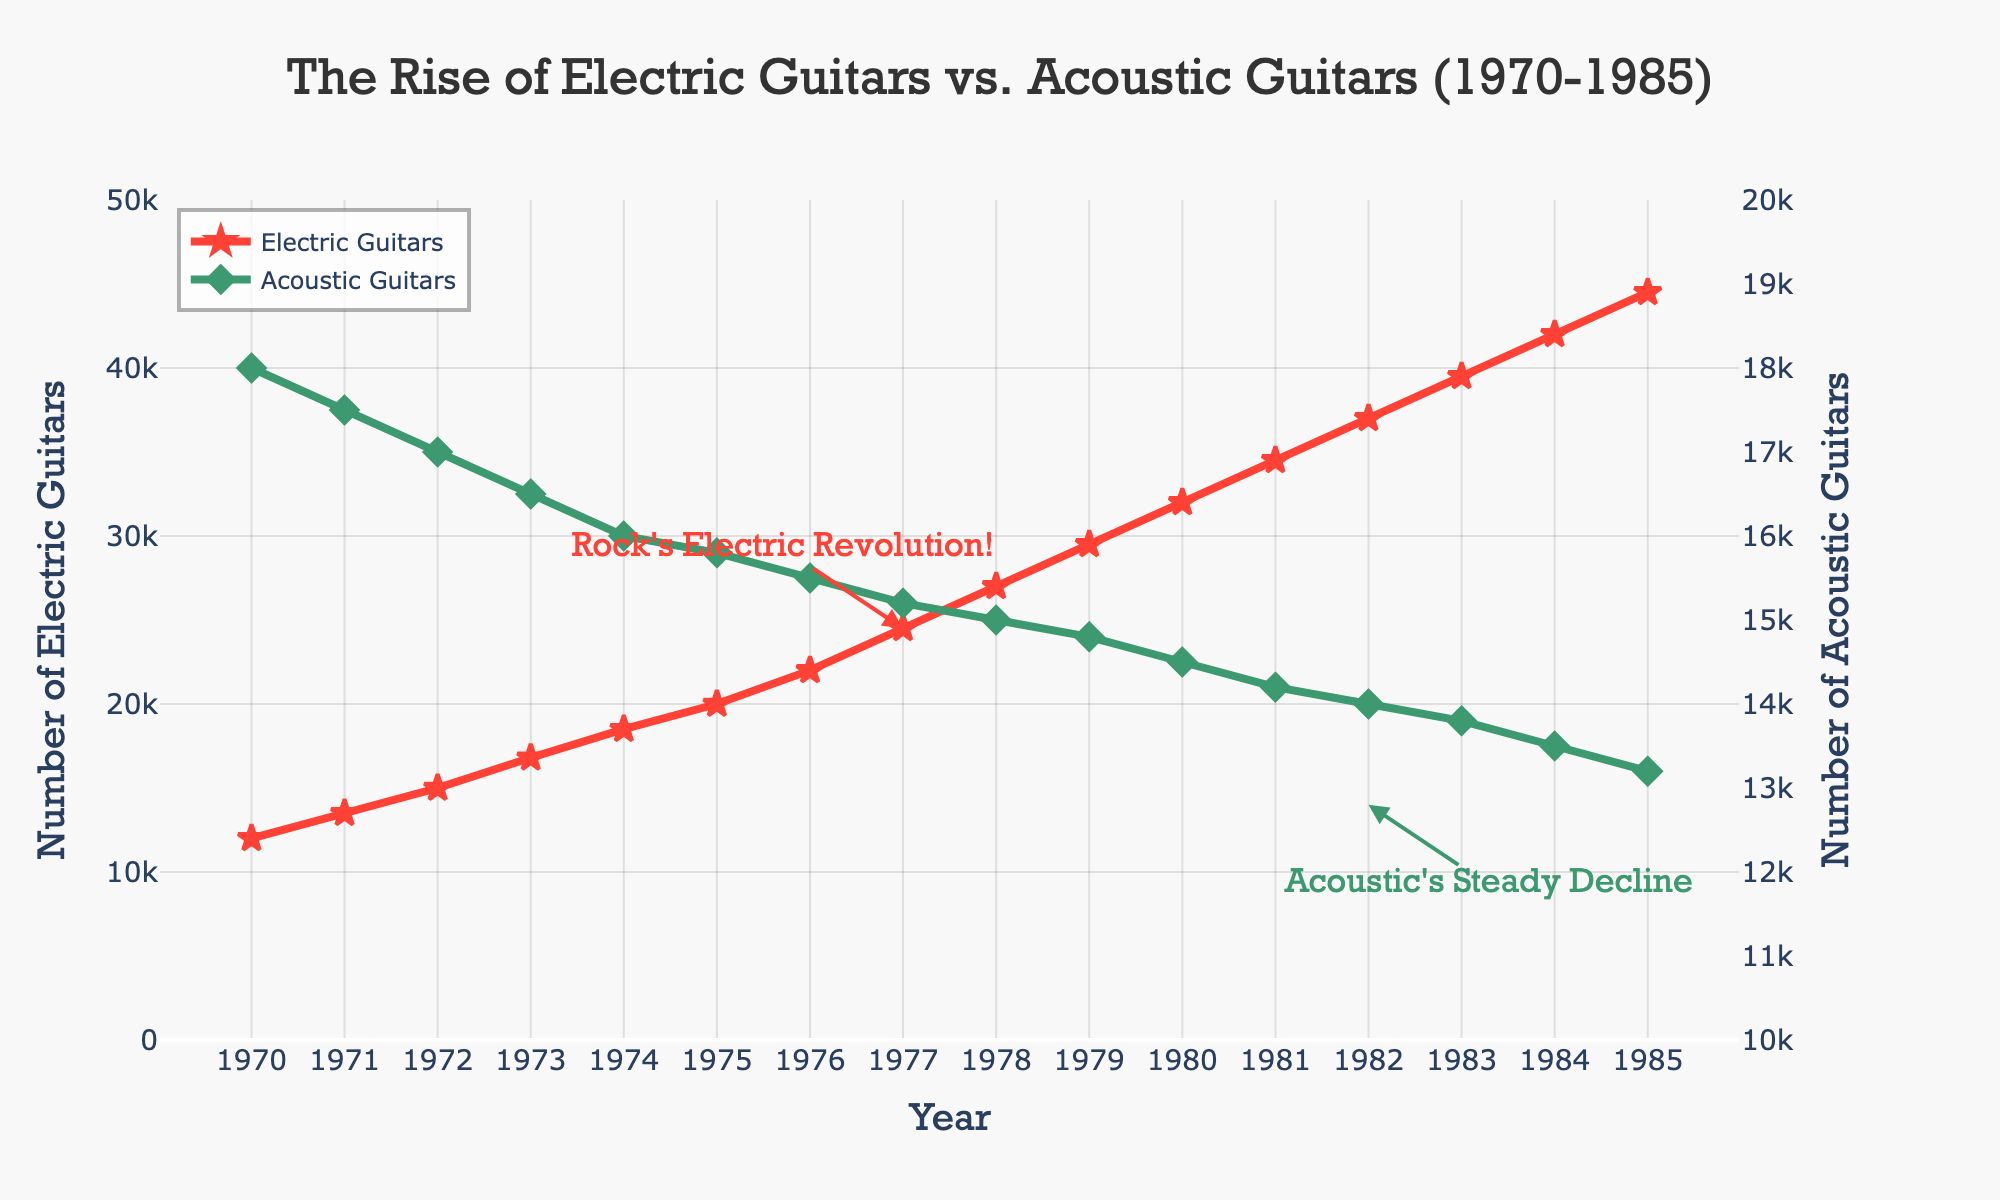What is the general trend of electric guitar sales from 1970 to 1985? The figure shows a consistent upward trend in the sales of electric guitars, starting at 12,000 in 1970 and reaching 44,500 in 1985. This indicates a strong and steady increase over the 15-year span.
Answer: Steady increase How did the sales of acoustic guitars change from 1970 to 1985? Unlike electric guitars, acoustic guitars show a downward trend. Sales decreased from 18,000 in 1970 to 13,200 in 1985, indicating a gradual decline over the years.
Answer: Gradual decline In what year did the electric guitars' sales surpass 30,000 units? According to the figure, electric guitar sales surpassed 30,000 units in 1980. This is deduced by observing the point where the electric guitar line crosses the 30,000 mark on the y-axis.
Answer: 1980 Compare the sales trends of electric and acoustic guitars in 1977. Which of the two had a higher sales rate? In 1977, the sales of electric guitars were 24,500 units and acoustic guitars were 15,200 units. Comparing these two values shows that electric guitars had a significantly higher sales rate.
Answer: Electric guitars During which period did acoustic guitar sales experience the most significant drop? The most significant drop in acoustic guitar sales appears to happen between 1973 and 1975, where the sales go from 16,500 to 15,800 units. The figure indicates a sharper decline during these years compared to other years.
Answer: 1973 to 1975 What are the colors used to represent electric and acoustic guitars in the figure? The figure uses red for electric guitars, represented by star-shaped markers, and green for acoustic guitars, represented by diamond-shaped markers.
Answer: Red and green How do the annotations in the figure help in understanding the trend? The annotations "Rock's Electric Revolution!" near 1977 and "Acoustic's Steady Decline" near 1982 help emphasize key points in the trend: a significant rise in electric guitar sales and a clear decline in acoustic guitar sales.
Answer: Emphasize trends What is the difference in electric guitar sales between 1970 and 1985? The sales of electric guitars in 1970 were 12,000 units, and in 1985, it was 44,500 units. The difference is calculated as 44,500 - 12,000 = 32,500 units.
Answer: 32,500 units What can you infer from the electric guitar sales in 1980 compared to acoustic guitar sales in the same year? In 1980, electric guitar sales were 32,000 units, whereas acoustic guitar sales were 14,500 units. This shows that electric guitar sales were significantly higher and the gap between them had widened compared to earlier years.
Answer: Electric much higher What logical operation can determine the average annual increase in electric guitar sales? To find the average annual increase, calculate the total increase (44,500 - 12,000 = 32,500) and then divide by the number of years (1985 - 1970 = 15). So, the average annual increase is 32,500 / 15 = 2,166.67.
Answer: 2,166.67 per year 